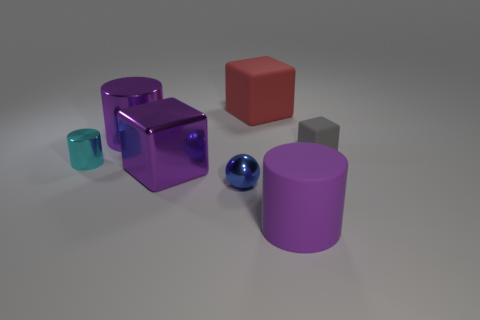Subtract all tiny gray cubes. How many cubes are left? 2 Subtract 1 blocks. How many blocks are left? 2 Subtract all purple blocks. How many blocks are left? 2 Add 1 large red blocks. How many objects exist? 8 Subtract all blocks. How many objects are left? 4 Subtract all purple cylinders. Subtract all brown spheres. How many cylinders are left? 1 Subtract all green cylinders. How many red blocks are left? 1 Subtract all tiny cylinders. Subtract all small blue shiny things. How many objects are left? 5 Add 1 large purple matte cylinders. How many large purple matte cylinders are left? 2 Add 3 large blue blocks. How many large blue blocks exist? 3 